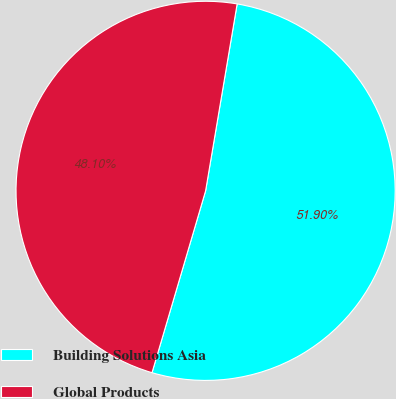Convert chart to OTSL. <chart><loc_0><loc_0><loc_500><loc_500><pie_chart><fcel>Building Solutions Asia<fcel>Global Products<nl><fcel>51.9%<fcel>48.1%<nl></chart> 